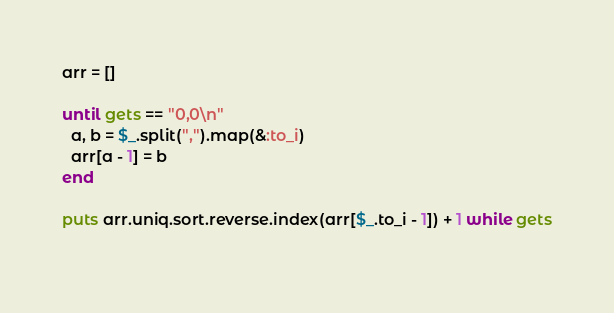Convert code to text. <code><loc_0><loc_0><loc_500><loc_500><_Ruby_>arr = []

until gets == "0,0\n"
  a, b = $_.split(",").map(&:to_i)
  arr[a - 1] = b
end

puts arr.uniq.sort.reverse.index(arr[$_.to_i - 1]) + 1 while gets
  </code> 